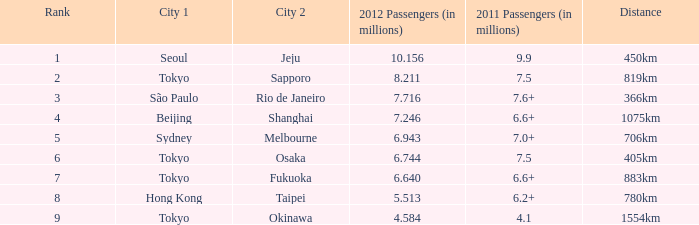How many passengers (in millions) flew from Seoul in 2012? 10.156. 